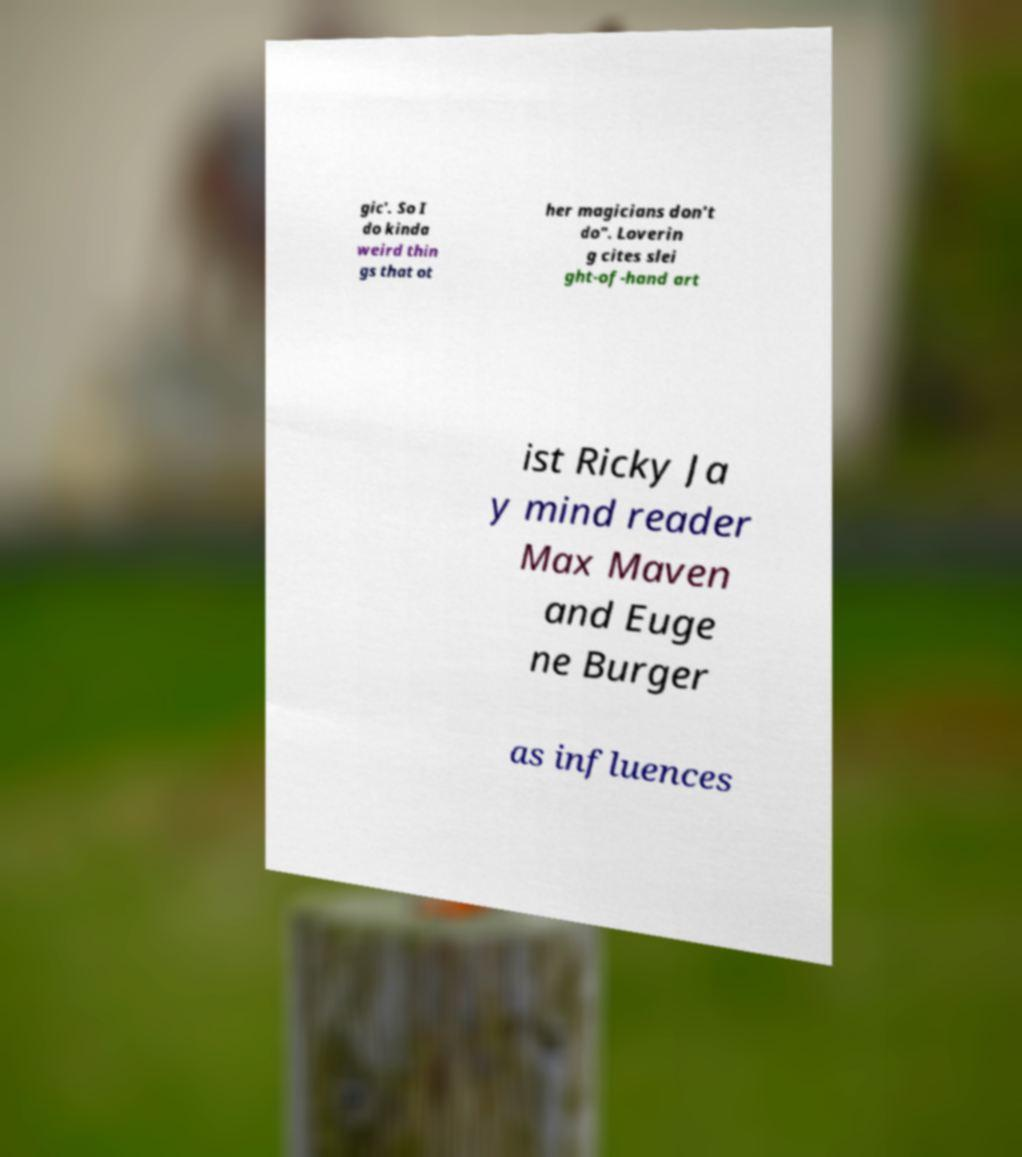For documentation purposes, I need the text within this image transcribed. Could you provide that? gic'. So I do kinda weird thin gs that ot her magicians don't do". Loverin g cites slei ght-of-hand art ist Ricky Ja y mind reader Max Maven and Euge ne Burger as influences 